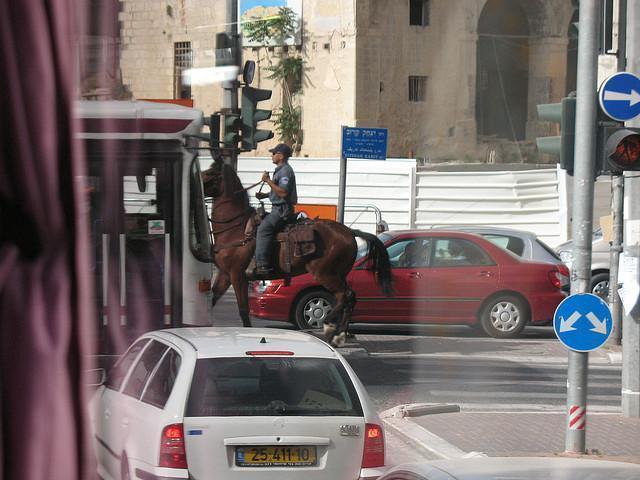How many cars are visible?
Give a very brief answer. 2. How many people can you see?
Give a very brief answer. 1. 